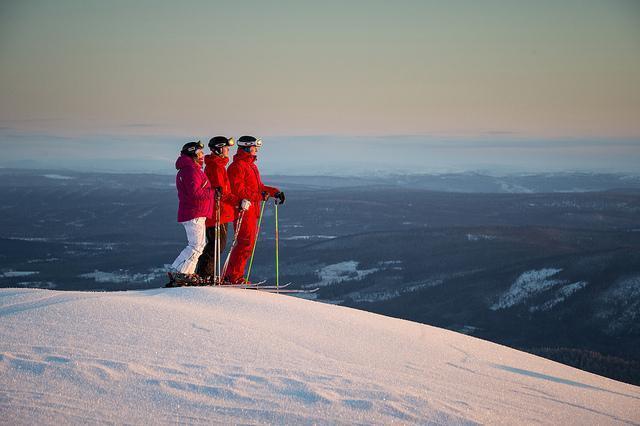What is the most likely time of day?
Select the accurate response from the four choices given to answer the question.
Options: Midnight, sunset, noon, morning. Sunset. 